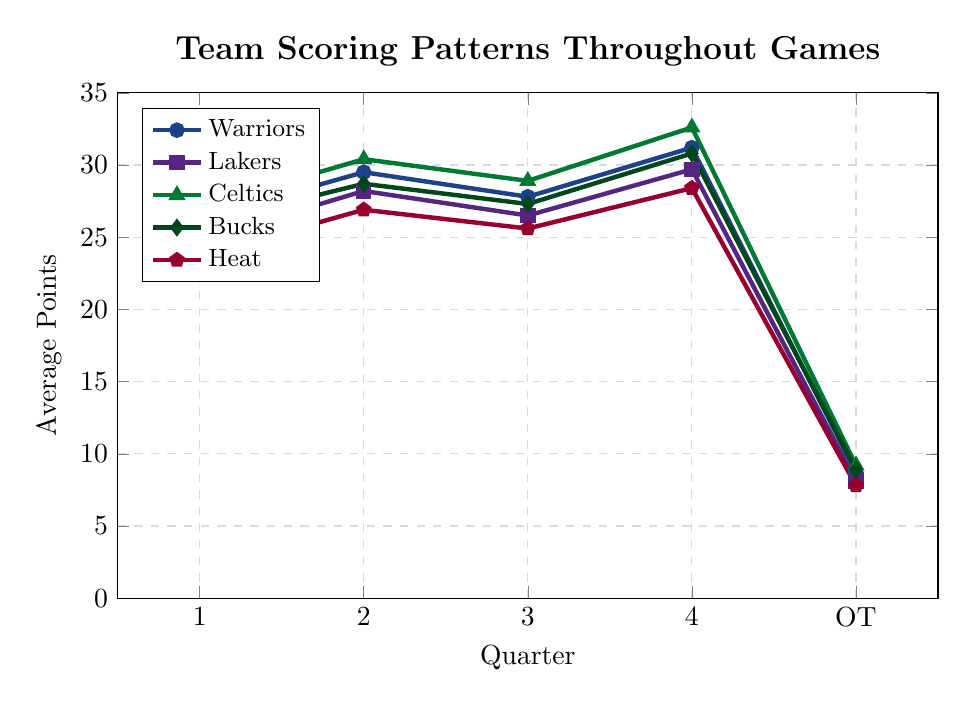Which team has the highest average points in the 4th quarter? To find the team with the highest average points in the 4th quarter, look at the data values for each team in the 4th quarter column. The Celtics have the highest with 32.6 points.
Answer: Celtics By how many points do the Warriors outscore the Heat in the 2nd quarter? Subtract the Heat's average points in the 2nd quarter (26.9) from the Warriors' average points in the 2nd quarter (29.5). 29.5 - 26.9 = 2.6.
Answer: 2.6 Which team shows the most significant increase from the 1st quarter to the 4th quarter? Calculate the difference for each team between their 1st and 4th quarter points: 
Warriors: 31.2 - 26.3 = 4.9
Lakers: 29.7 - 24.8 = 4.9
Celtics: 32.6 - 27.1 = 5.5
Bucks: 30.8 - 25.9 = 4.9
Heat: 28.4 - 23.7 = 4.7
The Celtics show the most significant increase of 5.5 points.
Answer: Celtics What is the average scoring of the Celtics across all quarters including OT? Add the Celtics' points across all quarters and OT and divide by the number of periods: (27.1 + 30.4 + 28.9 + 32.6 + 9.2) / 5. The sum is 128.2, and 128.2 / 5 = 25.64.
Answer: 25.64 Compare and contrast the scoring patterns of the Bucks and Lakers in the 3rd and 4th quarters. For the 3rd quarter, the Bucks have 27.3 points, and the Lakers have 26.5 points; thus, the Bucks score 0.8 points more. For the 4th quarter, the Bucks have 30.8 points, and the Lakers have 29.7 points; thus, the Bucks score 1.1 points more.
Answer: The Bucks outscore the Lakers in both the 3rd and 4th quarters by 0.8 and 1.1 points respectively Which team has the most consistent scoring (least variation) across the regular four quarters (1st to 4th)? Calculate the range for each team across the 1st to 4th quarters:
Warriors: 31.2 - 26.3 = 4.9
Lakers: 29.7 - 24.8 = 4.9
Celtics: 32.6 - 27.1 = 5.5
Bucks: 30.8 - 25.9 = 4.9
Heat: 28.4 - 23.7 = 4.7
The Heat have the least variation, with a range of 4.7.
Answer: Heat What's the sum of the Celtics' and Bucks' average points in the OT period? Add the Celtics' OT points (9.2) and the Bucks' OT points (8.9). 9.2 + 8.9 = 18.1.
Answer: 18.1 Which team has the lowest average points in any given quarter? Check the lowest value in any quarter for each team:
Warriors: 8.7 (OT)
Lakers: 8.1 (OT)
Celtics: 9.2 (OT)
Bucks: 8.9 (OT)
Heat: 7.8 (OT)
The Heat have the lowest average points in OT, with 7.8 points.
Answer: Heat By how many points do the Celtics outscore the Lakers in the 2nd quarter? Subtract the Lakers' average points in the 2nd quarter (28.2) from the Celtics' average points in the 2nd quarter (30.4). 30.4 - 28.2 = 2.2.
Answer: 2.2 